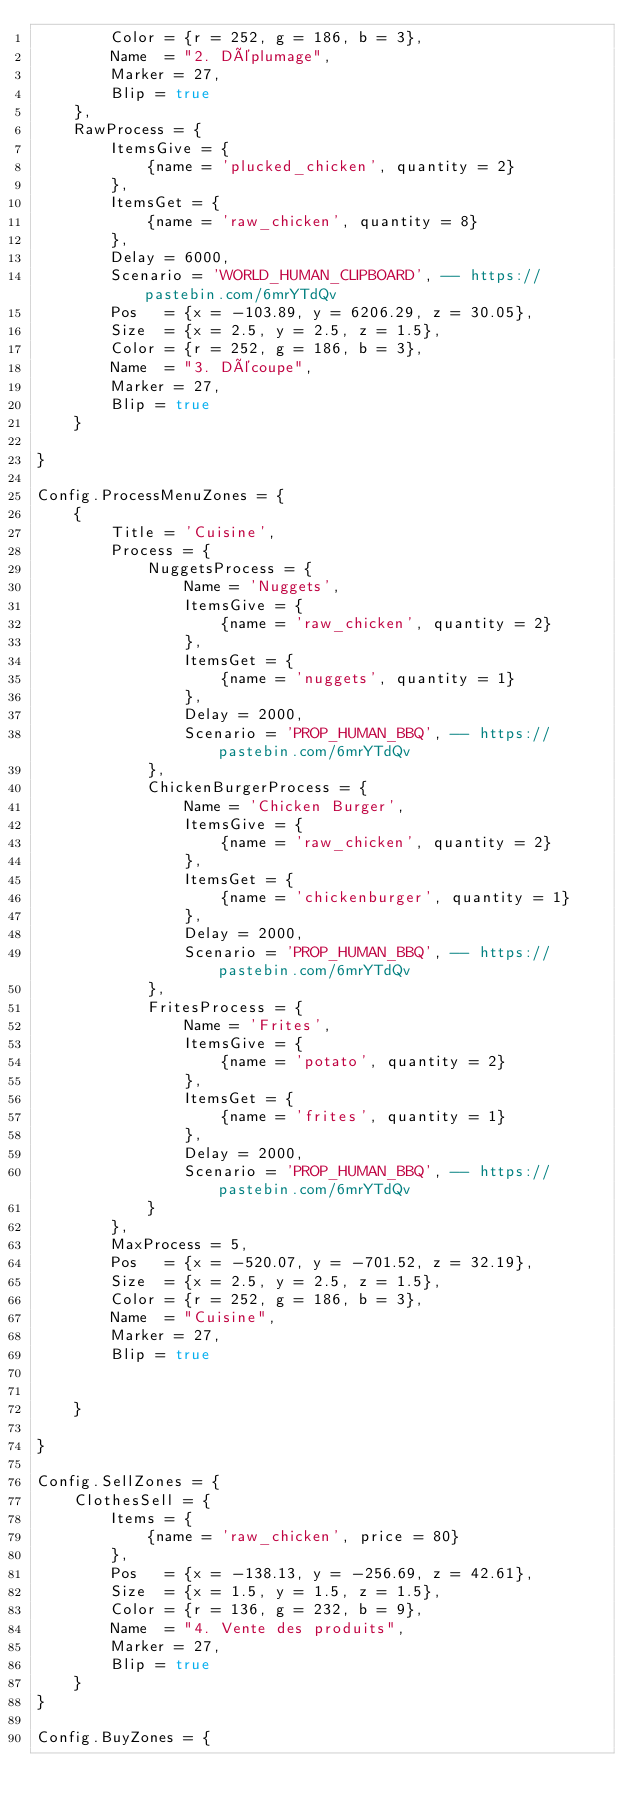Convert code to text. <code><loc_0><loc_0><loc_500><loc_500><_Lua_>		Color = {r = 252, g = 186, b = 3},
		Name  = "2. Déplumage",
		Marker = 27,
		Blip = true
	},
	RawProcess = {
		ItemsGive = {
			{name = 'plucked_chicken', quantity = 2}
		},
		ItemsGet = {
			{name = 'raw_chicken', quantity = 8}
		},
		Delay = 6000,
		Scenario = 'WORLD_HUMAN_CLIPBOARD', -- https://pastebin.com/6mrYTdQv
		Pos   = {x = -103.89, y = 6206.29, z = 30.05},
		Size  = {x = 2.5, y = 2.5, z = 1.5},
		Color = {r = 252, g = 186, b = 3},
		Name  = "3. Découpe",
		Marker = 27,
		Blip = true
	}

}

Config.ProcessMenuZones = {
	{
		Title = 'Cuisine',
		Process = {
			NuggetsProcess = {
				Name = 'Nuggets',
				ItemsGive = {
					{name = 'raw_chicken', quantity = 2}
				},
				ItemsGet = {
					{name = 'nuggets', quantity = 1}
				},
				Delay = 2000,
				Scenario = 'PROP_HUMAN_BBQ', -- https://pastebin.com/6mrYTdQv
			},
			ChickenBurgerProcess = {
				Name = 'Chicken Burger',
				ItemsGive = {
					{name = 'raw_chicken', quantity = 2}
				},
				ItemsGet = {
					{name = 'chickenburger', quantity = 1}
				},
				Delay = 2000,
				Scenario = 'PROP_HUMAN_BBQ', -- https://pastebin.com/6mrYTdQv
			},
			FritesProcess = {
				Name = 'Frites',
				ItemsGive = {
					{name = 'potato', quantity = 2}
				},
				ItemsGet = {
					{name = 'frites', quantity = 1}
				},
				Delay = 2000,
				Scenario = 'PROP_HUMAN_BBQ', -- https://pastebin.com/6mrYTdQv
			}
		},
		MaxProcess = 5,
		Pos   = {x = -520.07, y = -701.52, z = 32.19},
		Size  = {x = 2.5, y = 2.5, z = 1.5},
		Color = {r = 252, g = 186, b = 3},
		Name  = "Cuisine",
		Marker = 27,
		Blip = true


	}

}

Config.SellZones = {
	ClothesSell = {
		Items = {
			{name = 'raw_chicken', price = 80}
		},
		Pos   = {x = -138.13, y = -256.69, z = 42.61},
		Size  = {x = 1.5, y = 1.5, z = 1.5},
		Color = {r = 136, g = 232, b = 9},
		Name  = "4. Vente des produits",
		Marker = 27,
		Blip = true
	}
}

Config.BuyZones = {</code> 